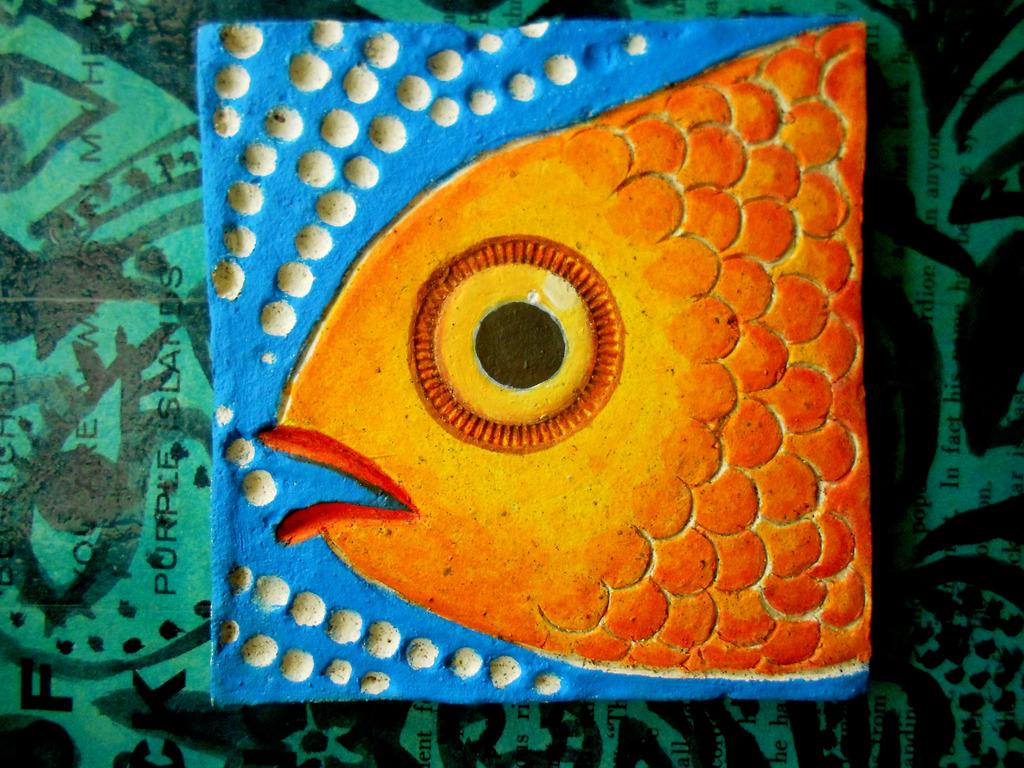What is depicted in the painting in the image? There is a painting of a fish and water in the image. Where is the painting located in the image? The painting is at the bottom of the image. What else can be seen in the image besides the painting? There is text in the image. How many horses are depicted in the painting in the image? There are no horses depicted in the painting; it features a fish and water. Is there a parcel being delivered in the image? There is no parcel or delivery depicted in the image. 